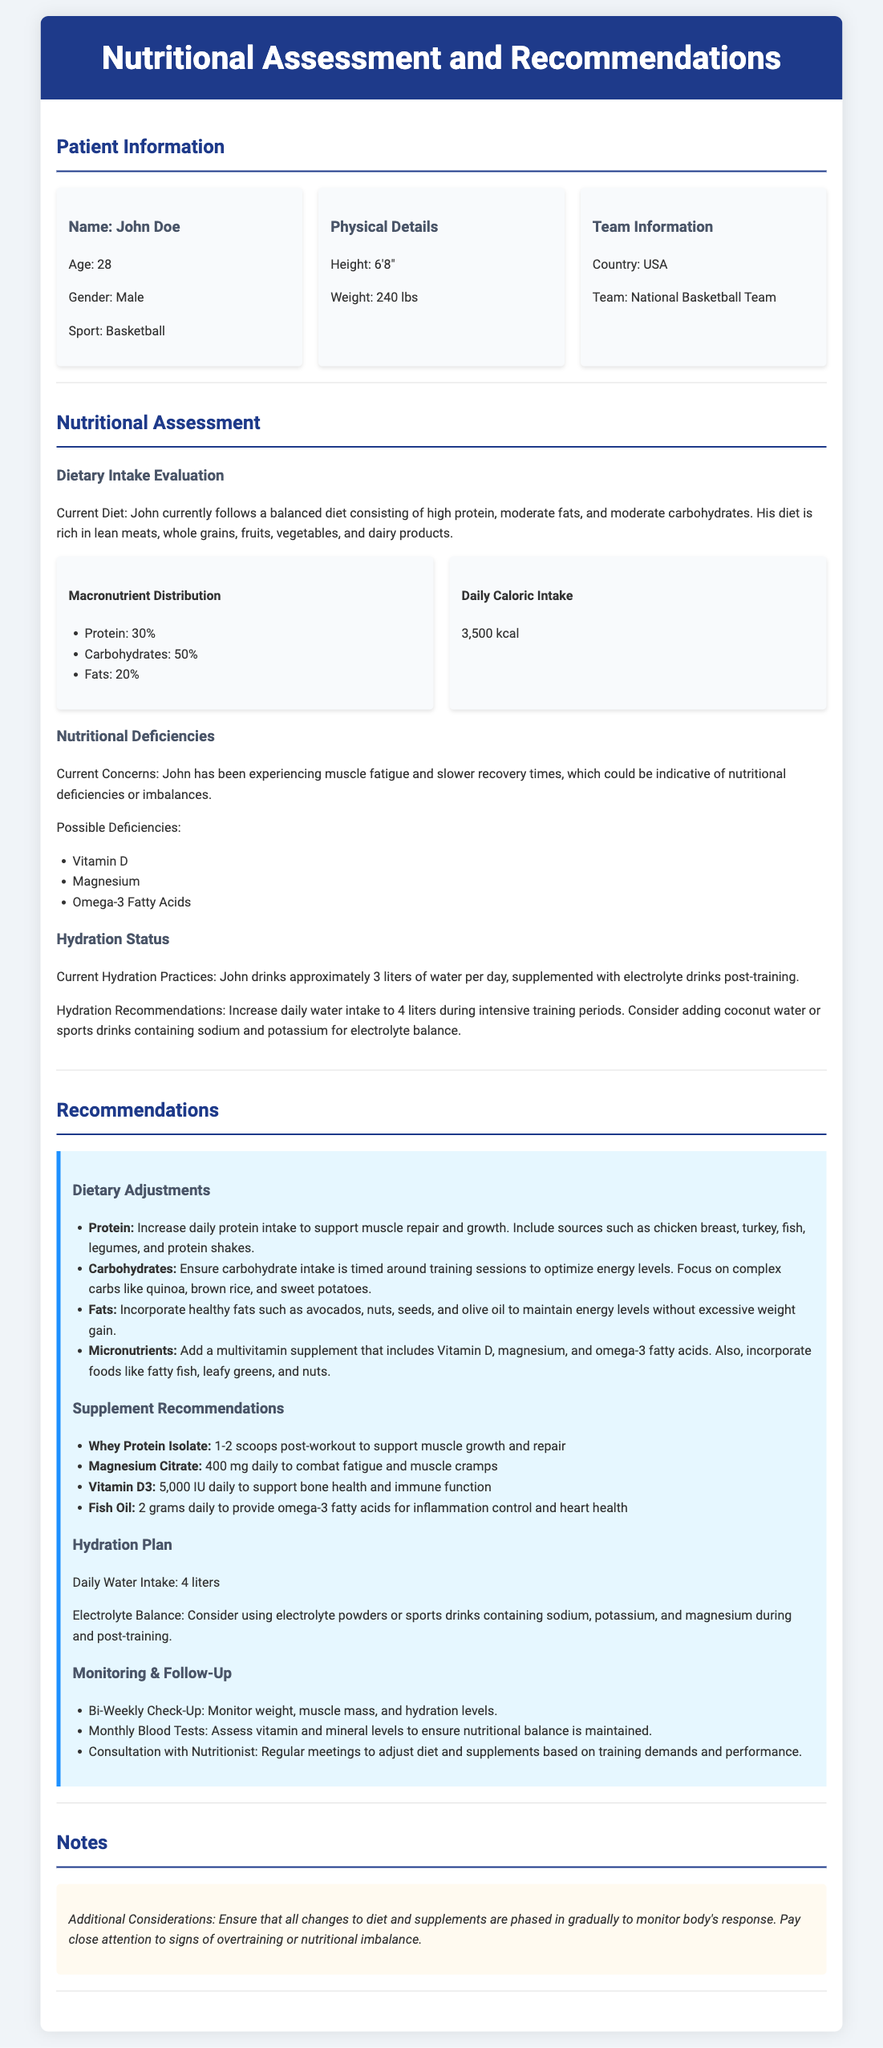What is the patient's name? The patient's name is provided in the Patient Information section.
Answer: John Doe How much does the patient weigh? The weight is mentioned under Physical Details in the document.
Answer: 240 lbs What is the patient's current daily caloric intake? The caloric intake is specified in the Nutritional Assessment section.
Answer: 3,500 kcal What percentage of the patient's diet consists of carbohydrates? The macronutrient distribution is listed in the Dietary Intake Evaluation.
Answer: 50% What deficiencies are noted for the patient? The nutritional deficiencies are listed in the Nutritional Deficiencies section of the document.
Answer: Vitamin D, Magnesium, Omega-3 Fatty Acids How much water should the patient drink daily during intensive training periods? The hydration recommendation specifies an increase in water intake during intensive training.
Answer: 4 liters What type of protein supplement is recommended for the patient? The Supplement Recommendations section includes the type of protein supplement beneficial for muscle growth and repair.
Answer: Whey Protein Isolate What is the recommended daily intake of Vitamin D3? The recommendation for Vitamin D3 is specified in the Supplement Recommendations section.
Answer: 5,000 IU What is the frequency of the patient's check-ups? The Monitoring & Follow-Up section mentions the frequency for check-ups.
Answer: Bi-Weekly 